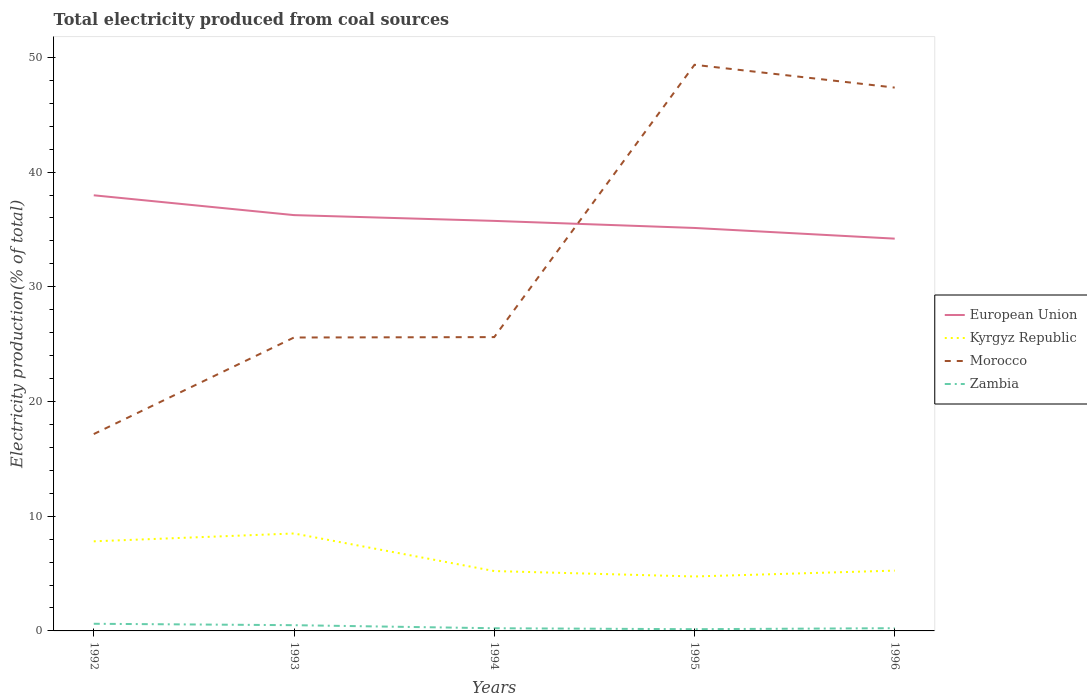How many different coloured lines are there?
Offer a very short reply. 4. Does the line corresponding to Morocco intersect with the line corresponding to Kyrgyz Republic?
Provide a succinct answer. No. Is the number of lines equal to the number of legend labels?
Give a very brief answer. Yes. Across all years, what is the maximum total electricity produced in Morocco?
Your response must be concise. 17.16. What is the total total electricity produced in Zambia in the graph?
Your response must be concise. 0.27. What is the difference between the highest and the second highest total electricity produced in Zambia?
Give a very brief answer. 0.47. What is the difference between the highest and the lowest total electricity produced in Morocco?
Make the answer very short. 2. Is the total electricity produced in Kyrgyz Republic strictly greater than the total electricity produced in European Union over the years?
Ensure brevity in your answer.  Yes. Are the values on the major ticks of Y-axis written in scientific E-notation?
Give a very brief answer. No. Does the graph contain grids?
Your answer should be compact. No. How are the legend labels stacked?
Provide a short and direct response. Vertical. What is the title of the graph?
Make the answer very short. Total electricity produced from coal sources. Does "Low income" appear as one of the legend labels in the graph?
Your answer should be compact. No. What is the label or title of the X-axis?
Your answer should be compact. Years. What is the label or title of the Y-axis?
Ensure brevity in your answer.  Electricity production(% of total). What is the Electricity production(% of total) of European Union in 1992?
Offer a very short reply. 37.98. What is the Electricity production(% of total) in Kyrgyz Republic in 1992?
Your answer should be very brief. 7.81. What is the Electricity production(% of total) in Morocco in 1992?
Keep it short and to the point. 17.16. What is the Electricity production(% of total) in Zambia in 1992?
Offer a terse response. 0.62. What is the Electricity production(% of total) in European Union in 1993?
Offer a very short reply. 36.25. What is the Electricity production(% of total) in Kyrgyz Republic in 1993?
Your answer should be very brief. 8.5. What is the Electricity production(% of total) in Morocco in 1993?
Provide a succinct answer. 25.58. What is the Electricity production(% of total) of Zambia in 1993?
Offer a very short reply. 0.5. What is the Electricity production(% of total) in European Union in 1994?
Offer a very short reply. 35.75. What is the Electricity production(% of total) of Kyrgyz Republic in 1994?
Offer a very short reply. 5.22. What is the Electricity production(% of total) in Morocco in 1994?
Offer a very short reply. 25.61. What is the Electricity production(% of total) in Zambia in 1994?
Give a very brief answer. 0.23. What is the Electricity production(% of total) in European Union in 1995?
Make the answer very short. 35.13. What is the Electricity production(% of total) of Kyrgyz Republic in 1995?
Offer a terse response. 4.75. What is the Electricity production(% of total) of Morocco in 1995?
Keep it short and to the point. 49.35. What is the Electricity production(% of total) in Zambia in 1995?
Provide a succinct answer. 0.15. What is the Electricity production(% of total) in European Union in 1996?
Offer a very short reply. 34.2. What is the Electricity production(% of total) in Kyrgyz Republic in 1996?
Your response must be concise. 5.26. What is the Electricity production(% of total) in Morocco in 1996?
Offer a very short reply. 47.37. What is the Electricity production(% of total) of Zambia in 1996?
Offer a very short reply. 0.24. Across all years, what is the maximum Electricity production(% of total) in European Union?
Provide a succinct answer. 37.98. Across all years, what is the maximum Electricity production(% of total) in Kyrgyz Republic?
Offer a very short reply. 8.5. Across all years, what is the maximum Electricity production(% of total) in Morocco?
Make the answer very short. 49.35. Across all years, what is the maximum Electricity production(% of total) in Zambia?
Your response must be concise. 0.62. Across all years, what is the minimum Electricity production(% of total) in European Union?
Make the answer very short. 34.2. Across all years, what is the minimum Electricity production(% of total) in Kyrgyz Republic?
Give a very brief answer. 4.75. Across all years, what is the minimum Electricity production(% of total) of Morocco?
Your response must be concise. 17.16. Across all years, what is the minimum Electricity production(% of total) of Zambia?
Provide a succinct answer. 0.15. What is the total Electricity production(% of total) of European Union in the graph?
Your answer should be very brief. 179.31. What is the total Electricity production(% of total) in Kyrgyz Republic in the graph?
Ensure brevity in your answer.  31.53. What is the total Electricity production(% of total) in Morocco in the graph?
Offer a terse response. 165.08. What is the total Electricity production(% of total) of Zambia in the graph?
Give a very brief answer. 1.75. What is the difference between the Electricity production(% of total) of European Union in 1992 and that in 1993?
Give a very brief answer. 1.73. What is the difference between the Electricity production(% of total) in Kyrgyz Republic in 1992 and that in 1993?
Ensure brevity in your answer.  -0.69. What is the difference between the Electricity production(% of total) in Morocco in 1992 and that in 1993?
Your answer should be compact. -8.42. What is the difference between the Electricity production(% of total) in Zambia in 1992 and that in 1993?
Offer a very short reply. 0.12. What is the difference between the Electricity production(% of total) of European Union in 1992 and that in 1994?
Your response must be concise. 2.23. What is the difference between the Electricity production(% of total) of Kyrgyz Republic in 1992 and that in 1994?
Make the answer very short. 2.59. What is the difference between the Electricity production(% of total) of Morocco in 1992 and that in 1994?
Make the answer very short. -8.45. What is the difference between the Electricity production(% of total) of Zambia in 1992 and that in 1994?
Your answer should be compact. 0.39. What is the difference between the Electricity production(% of total) in European Union in 1992 and that in 1995?
Provide a short and direct response. 2.85. What is the difference between the Electricity production(% of total) in Kyrgyz Republic in 1992 and that in 1995?
Give a very brief answer. 3.06. What is the difference between the Electricity production(% of total) of Morocco in 1992 and that in 1995?
Your answer should be compact. -32.19. What is the difference between the Electricity production(% of total) in Zambia in 1992 and that in 1995?
Give a very brief answer. 0.47. What is the difference between the Electricity production(% of total) in European Union in 1992 and that in 1996?
Ensure brevity in your answer.  3.78. What is the difference between the Electricity production(% of total) in Kyrgyz Republic in 1992 and that in 1996?
Keep it short and to the point. 2.55. What is the difference between the Electricity production(% of total) in Morocco in 1992 and that in 1996?
Offer a terse response. -30.21. What is the difference between the Electricity production(% of total) of Zambia in 1992 and that in 1996?
Provide a short and direct response. 0.39. What is the difference between the Electricity production(% of total) in European Union in 1993 and that in 1994?
Your answer should be very brief. 0.5. What is the difference between the Electricity production(% of total) in Kyrgyz Republic in 1993 and that in 1994?
Your answer should be compact. 3.28. What is the difference between the Electricity production(% of total) of Morocco in 1993 and that in 1994?
Your answer should be compact. -0.03. What is the difference between the Electricity production(% of total) of Zambia in 1993 and that in 1994?
Ensure brevity in your answer.  0.27. What is the difference between the Electricity production(% of total) in European Union in 1993 and that in 1995?
Your answer should be very brief. 1.12. What is the difference between the Electricity production(% of total) in Kyrgyz Republic in 1993 and that in 1995?
Offer a terse response. 3.75. What is the difference between the Electricity production(% of total) in Morocco in 1993 and that in 1995?
Your response must be concise. -23.77. What is the difference between the Electricity production(% of total) in Zambia in 1993 and that in 1995?
Offer a very short reply. 0.35. What is the difference between the Electricity production(% of total) in European Union in 1993 and that in 1996?
Offer a very short reply. 2.05. What is the difference between the Electricity production(% of total) of Kyrgyz Republic in 1993 and that in 1996?
Provide a succinct answer. 3.24. What is the difference between the Electricity production(% of total) of Morocco in 1993 and that in 1996?
Your answer should be very brief. -21.79. What is the difference between the Electricity production(% of total) in Zambia in 1993 and that in 1996?
Your response must be concise. 0.26. What is the difference between the Electricity production(% of total) of European Union in 1994 and that in 1995?
Make the answer very short. 0.62. What is the difference between the Electricity production(% of total) in Kyrgyz Republic in 1994 and that in 1995?
Ensure brevity in your answer.  0.47. What is the difference between the Electricity production(% of total) of Morocco in 1994 and that in 1995?
Offer a terse response. -23.74. What is the difference between the Electricity production(% of total) of Zambia in 1994 and that in 1995?
Offer a terse response. 0.08. What is the difference between the Electricity production(% of total) in European Union in 1994 and that in 1996?
Make the answer very short. 1.55. What is the difference between the Electricity production(% of total) in Kyrgyz Republic in 1994 and that in 1996?
Your answer should be compact. -0.04. What is the difference between the Electricity production(% of total) in Morocco in 1994 and that in 1996?
Your answer should be very brief. -21.75. What is the difference between the Electricity production(% of total) in Zambia in 1994 and that in 1996?
Your answer should be very brief. -0. What is the difference between the Electricity production(% of total) of European Union in 1995 and that in 1996?
Make the answer very short. 0.93. What is the difference between the Electricity production(% of total) in Kyrgyz Republic in 1995 and that in 1996?
Provide a succinct answer. -0.51. What is the difference between the Electricity production(% of total) in Morocco in 1995 and that in 1996?
Your response must be concise. 1.99. What is the difference between the Electricity production(% of total) in Zambia in 1995 and that in 1996?
Keep it short and to the point. -0.09. What is the difference between the Electricity production(% of total) of European Union in 1992 and the Electricity production(% of total) of Kyrgyz Republic in 1993?
Your answer should be very brief. 29.48. What is the difference between the Electricity production(% of total) in European Union in 1992 and the Electricity production(% of total) in Morocco in 1993?
Give a very brief answer. 12.4. What is the difference between the Electricity production(% of total) of European Union in 1992 and the Electricity production(% of total) of Zambia in 1993?
Keep it short and to the point. 37.48. What is the difference between the Electricity production(% of total) of Kyrgyz Republic in 1992 and the Electricity production(% of total) of Morocco in 1993?
Provide a short and direct response. -17.77. What is the difference between the Electricity production(% of total) of Kyrgyz Republic in 1992 and the Electricity production(% of total) of Zambia in 1993?
Your answer should be very brief. 7.31. What is the difference between the Electricity production(% of total) in Morocco in 1992 and the Electricity production(% of total) in Zambia in 1993?
Offer a very short reply. 16.66. What is the difference between the Electricity production(% of total) in European Union in 1992 and the Electricity production(% of total) in Kyrgyz Republic in 1994?
Your answer should be very brief. 32.76. What is the difference between the Electricity production(% of total) of European Union in 1992 and the Electricity production(% of total) of Morocco in 1994?
Your answer should be very brief. 12.36. What is the difference between the Electricity production(% of total) in European Union in 1992 and the Electricity production(% of total) in Zambia in 1994?
Give a very brief answer. 37.74. What is the difference between the Electricity production(% of total) of Kyrgyz Republic in 1992 and the Electricity production(% of total) of Morocco in 1994?
Your answer should be compact. -17.8. What is the difference between the Electricity production(% of total) in Kyrgyz Republic in 1992 and the Electricity production(% of total) in Zambia in 1994?
Offer a very short reply. 7.58. What is the difference between the Electricity production(% of total) in Morocco in 1992 and the Electricity production(% of total) in Zambia in 1994?
Offer a very short reply. 16.93. What is the difference between the Electricity production(% of total) in European Union in 1992 and the Electricity production(% of total) in Kyrgyz Republic in 1995?
Offer a terse response. 33.23. What is the difference between the Electricity production(% of total) of European Union in 1992 and the Electricity production(% of total) of Morocco in 1995?
Provide a short and direct response. -11.38. What is the difference between the Electricity production(% of total) of European Union in 1992 and the Electricity production(% of total) of Zambia in 1995?
Your response must be concise. 37.83. What is the difference between the Electricity production(% of total) of Kyrgyz Republic in 1992 and the Electricity production(% of total) of Morocco in 1995?
Give a very brief answer. -41.54. What is the difference between the Electricity production(% of total) of Kyrgyz Republic in 1992 and the Electricity production(% of total) of Zambia in 1995?
Your answer should be very brief. 7.66. What is the difference between the Electricity production(% of total) of Morocco in 1992 and the Electricity production(% of total) of Zambia in 1995?
Keep it short and to the point. 17.01. What is the difference between the Electricity production(% of total) in European Union in 1992 and the Electricity production(% of total) in Kyrgyz Republic in 1996?
Make the answer very short. 32.72. What is the difference between the Electricity production(% of total) of European Union in 1992 and the Electricity production(% of total) of Morocco in 1996?
Provide a short and direct response. -9.39. What is the difference between the Electricity production(% of total) in European Union in 1992 and the Electricity production(% of total) in Zambia in 1996?
Your answer should be compact. 37.74. What is the difference between the Electricity production(% of total) in Kyrgyz Republic in 1992 and the Electricity production(% of total) in Morocco in 1996?
Offer a very short reply. -39.56. What is the difference between the Electricity production(% of total) of Kyrgyz Republic in 1992 and the Electricity production(% of total) of Zambia in 1996?
Provide a short and direct response. 7.57. What is the difference between the Electricity production(% of total) of Morocco in 1992 and the Electricity production(% of total) of Zambia in 1996?
Offer a terse response. 16.93. What is the difference between the Electricity production(% of total) in European Union in 1993 and the Electricity production(% of total) in Kyrgyz Republic in 1994?
Provide a succinct answer. 31.03. What is the difference between the Electricity production(% of total) of European Union in 1993 and the Electricity production(% of total) of Morocco in 1994?
Keep it short and to the point. 10.64. What is the difference between the Electricity production(% of total) in European Union in 1993 and the Electricity production(% of total) in Zambia in 1994?
Make the answer very short. 36.02. What is the difference between the Electricity production(% of total) in Kyrgyz Republic in 1993 and the Electricity production(% of total) in Morocco in 1994?
Ensure brevity in your answer.  -17.12. What is the difference between the Electricity production(% of total) of Kyrgyz Republic in 1993 and the Electricity production(% of total) of Zambia in 1994?
Your answer should be very brief. 8.26. What is the difference between the Electricity production(% of total) in Morocco in 1993 and the Electricity production(% of total) in Zambia in 1994?
Ensure brevity in your answer.  25.35. What is the difference between the Electricity production(% of total) in European Union in 1993 and the Electricity production(% of total) in Kyrgyz Republic in 1995?
Your answer should be compact. 31.5. What is the difference between the Electricity production(% of total) in European Union in 1993 and the Electricity production(% of total) in Morocco in 1995?
Provide a succinct answer. -13.1. What is the difference between the Electricity production(% of total) of European Union in 1993 and the Electricity production(% of total) of Zambia in 1995?
Give a very brief answer. 36.1. What is the difference between the Electricity production(% of total) in Kyrgyz Republic in 1993 and the Electricity production(% of total) in Morocco in 1995?
Provide a succinct answer. -40.86. What is the difference between the Electricity production(% of total) in Kyrgyz Republic in 1993 and the Electricity production(% of total) in Zambia in 1995?
Make the answer very short. 8.34. What is the difference between the Electricity production(% of total) in Morocco in 1993 and the Electricity production(% of total) in Zambia in 1995?
Offer a very short reply. 25.43. What is the difference between the Electricity production(% of total) of European Union in 1993 and the Electricity production(% of total) of Kyrgyz Republic in 1996?
Provide a succinct answer. 30.99. What is the difference between the Electricity production(% of total) of European Union in 1993 and the Electricity production(% of total) of Morocco in 1996?
Ensure brevity in your answer.  -11.12. What is the difference between the Electricity production(% of total) of European Union in 1993 and the Electricity production(% of total) of Zambia in 1996?
Provide a succinct answer. 36.01. What is the difference between the Electricity production(% of total) of Kyrgyz Republic in 1993 and the Electricity production(% of total) of Morocco in 1996?
Provide a succinct answer. -38.87. What is the difference between the Electricity production(% of total) of Kyrgyz Republic in 1993 and the Electricity production(% of total) of Zambia in 1996?
Make the answer very short. 8.26. What is the difference between the Electricity production(% of total) of Morocco in 1993 and the Electricity production(% of total) of Zambia in 1996?
Ensure brevity in your answer.  25.34. What is the difference between the Electricity production(% of total) in European Union in 1994 and the Electricity production(% of total) in Kyrgyz Republic in 1995?
Make the answer very short. 31. What is the difference between the Electricity production(% of total) of European Union in 1994 and the Electricity production(% of total) of Morocco in 1995?
Offer a very short reply. -13.61. What is the difference between the Electricity production(% of total) of European Union in 1994 and the Electricity production(% of total) of Zambia in 1995?
Give a very brief answer. 35.6. What is the difference between the Electricity production(% of total) of Kyrgyz Republic in 1994 and the Electricity production(% of total) of Morocco in 1995?
Provide a succinct answer. -44.14. What is the difference between the Electricity production(% of total) of Kyrgyz Republic in 1994 and the Electricity production(% of total) of Zambia in 1995?
Ensure brevity in your answer.  5.07. What is the difference between the Electricity production(% of total) of Morocco in 1994 and the Electricity production(% of total) of Zambia in 1995?
Keep it short and to the point. 25.46. What is the difference between the Electricity production(% of total) in European Union in 1994 and the Electricity production(% of total) in Kyrgyz Republic in 1996?
Provide a succinct answer. 30.49. What is the difference between the Electricity production(% of total) of European Union in 1994 and the Electricity production(% of total) of Morocco in 1996?
Provide a short and direct response. -11.62. What is the difference between the Electricity production(% of total) in European Union in 1994 and the Electricity production(% of total) in Zambia in 1996?
Keep it short and to the point. 35.51. What is the difference between the Electricity production(% of total) in Kyrgyz Republic in 1994 and the Electricity production(% of total) in Morocco in 1996?
Offer a terse response. -42.15. What is the difference between the Electricity production(% of total) in Kyrgyz Republic in 1994 and the Electricity production(% of total) in Zambia in 1996?
Give a very brief answer. 4.98. What is the difference between the Electricity production(% of total) of Morocco in 1994 and the Electricity production(% of total) of Zambia in 1996?
Offer a very short reply. 25.38. What is the difference between the Electricity production(% of total) in European Union in 1995 and the Electricity production(% of total) in Kyrgyz Republic in 1996?
Provide a succinct answer. 29.87. What is the difference between the Electricity production(% of total) of European Union in 1995 and the Electricity production(% of total) of Morocco in 1996?
Provide a succinct answer. -12.24. What is the difference between the Electricity production(% of total) in European Union in 1995 and the Electricity production(% of total) in Zambia in 1996?
Provide a short and direct response. 34.89. What is the difference between the Electricity production(% of total) in Kyrgyz Republic in 1995 and the Electricity production(% of total) in Morocco in 1996?
Offer a very short reply. -42.62. What is the difference between the Electricity production(% of total) in Kyrgyz Republic in 1995 and the Electricity production(% of total) in Zambia in 1996?
Your response must be concise. 4.51. What is the difference between the Electricity production(% of total) in Morocco in 1995 and the Electricity production(% of total) in Zambia in 1996?
Offer a very short reply. 49.12. What is the average Electricity production(% of total) of European Union per year?
Offer a very short reply. 35.86. What is the average Electricity production(% of total) of Kyrgyz Republic per year?
Provide a succinct answer. 6.31. What is the average Electricity production(% of total) of Morocco per year?
Offer a very short reply. 33.02. What is the average Electricity production(% of total) of Zambia per year?
Your answer should be compact. 0.35. In the year 1992, what is the difference between the Electricity production(% of total) in European Union and Electricity production(% of total) in Kyrgyz Republic?
Keep it short and to the point. 30.17. In the year 1992, what is the difference between the Electricity production(% of total) in European Union and Electricity production(% of total) in Morocco?
Offer a very short reply. 20.82. In the year 1992, what is the difference between the Electricity production(% of total) of European Union and Electricity production(% of total) of Zambia?
Offer a terse response. 37.35. In the year 1992, what is the difference between the Electricity production(% of total) in Kyrgyz Republic and Electricity production(% of total) in Morocco?
Give a very brief answer. -9.35. In the year 1992, what is the difference between the Electricity production(% of total) of Kyrgyz Republic and Electricity production(% of total) of Zambia?
Your response must be concise. 7.19. In the year 1992, what is the difference between the Electricity production(% of total) of Morocco and Electricity production(% of total) of Zambia?
Offer a very short reply. 16.54. In the year 1993, what is the difference between the Electricity production(% of total) of European Union and Electricity production(% of total) of Kyrgyz Republic?
Your response must be concise. 27.75. In the year 1993, what is the difference between the Electricity production(% of total) of European Union and Electricity production(% of total) of Morocco?
Provide a short and direct response. 10.67. In the year 1993, what is the difference between the Electricity production(% of total) of European Union and Electricity production(% of total) of Zambia?
Give a very brief answer. 35.75. In the year 1993, what is the difference between the Electricity production(% of total) in Kyrgyz Republic and Electricity production(% of total) in Morocco?
Provide a succinct answer. -17.08. In the year 1993, what is the difference between the Electricity production(% of total) in Kyrgyz Republic and Electricity production(% of total) in Zambia?
Provide a short and direct response. 8. In the year 1993, what is the difference between the Electricity production(% of total) in Morocco and Electricity production(% of total) in Zambia?
Make the answer very short. 25.08. In the year 1994, what is the difference between the Electricity production(% of total) in European Union and Electricity production(% of total) in Kyrgyz Republic?
Your answer should be very brief. 30.53. In the year 1994, what is the difference between the Electricity production(% of total) of European Union and Electricity production(% of total) of Morocco?
Provide a succinct answer. 10.13. In the year 1994, what is the difference between the Electricity production(% of total) in European Union and Electricity production(% of total) in Zambia?
Ensure brevity in your answer.  35.51. In the year 1994, what is the difference between the Electricity production(% of total) of Kyrgyz Republic and Electricity production(% of total) of Morocco?
Your answer should be compact. -20.4. In the year 1994, what is the difference between the Electricity production(% of total) of Kyrgyz Republic and Electricity production(% of total) of Zambia?
Your response must be concise. 4.99. In the year 1994, what is the difference between the Electricity production(% of total) in Morocco and Electricity production(% of total) in Zambia?
Make the answer very short. 25.38. In the year 1995, what is the difference between the Electricity production(% of total) of European Union and Electricity production(% of total) of Kyrgyz Republic?
Your response must be concise. 30.38. In the year 1995, what is the difference between the Electricity production(% of total) of European Union and Electricity production(% of total) of Morocco?
Your answer should be very brief. -14.22. In the year 1995, what is the difference between the Electricity production(% of total) of European Union and Electricity production(% of total) of Zambia?
Your answer should be compact. 34.98. In the year 1995, what is the difference between the Electricity production(% of total) of Kyrgyz Republic and Electricity production(% of total) of Morocco?
Provide a short and direct response. -44.61. In the year 1995, what is the difference between the Electricity production(% of total) of Kyrgyz Republic and Electricity production(% of total) of Zambia?
Keep it short and to the point. 4.59. In the year 1995, what is the difference between the Electricity production(% of total) of Morocco and Electricity production(% of total) of Zambia?
Your response must be concise. 49.2. In the year 1996, what is the difference between the Electricity production(% of total) in European Union and Electricity production(% of total) in Kyrgyz Republic?
Provide a succinct answer. 28.94. In the year 1996, what is the difference between the Electricity production(% of total) in European Union and Electricity production(% of total) in Morocco?
Your answer should be very brief. -13.17. In the year 1996, what is the difference between the Electricity production(% of total) in European Union and Electricity production(% of total) in Zambia?
Make the answer very short. 33.96. In the year 1996, what is the difference between the Electricity production(% of total) in Kyrgyz Republic and Electricity production(% of total) in Morocco?
Offer a terse response. -42.11. In the year 1996, what is the difference between the Electricity production(% of total) of Kyrgyz Republic and Electricity production(% of total) of Zambia?
Keep it short and to the point. 5.02. In the year 1996, what is the difference between the Electricity production(% of total) of Morocco and Electricity production(% of total) of Zambia?
Your answer should be very brief. 47.13. What is the ratio of the Electricity production(% of total) of European Union in 1992 to that in 1993?
Your answer should be very brief. 1.05. What is the ratio of the Electricity production(% of total) of Kyrgyz Republic in 1992 to that in 1993?
Provide a succinct answer. 0.92. What is the ratio of the Electricity production(% of total) in Morocco in 1992 to that in 1993?
Give a very brief answer. 0.67. What is the ratio of the Electricity production(% of total) in Zambia in 1992 to that in 1993?
Provide a short and direct response. 1.25. What is the ratio of the Electricity production(% of total) of European Union in 1992 to that in 1994?
Keep it short and to the point. 1.06. What is the ratio of the Electricity production(% of total) in Kyrgyz Republic in 1992 to that in 1994?
Ensure brevity in your answer.  1.5. What is the ratio of the Electricity production(% of total) of Morocco in 1992 to that in 1994?
Your answer should be very brief. 0.67. What is the ratio of the Electricity production(% of total) of Zambia in 1992 to that in 1994?
Give a very brief answer. 2.67. What is the ratio of the Electricity production(% of total) in European Union in 1992 to that in 1995?
Your response must be concise. 1.08. What is the ratio of the Electricity production(% of total) in Kyrgyz Republic in 1992 to that in 1995?
Offer a terse response. 1.65. What is the ratio of the Electricity production(% of total) in Morocco in 1992 to that in 1995?
Your answer should be compact. 0.35. What is the ratio of the Electricity production(% of total) of Zambia in 1992 to that in 1995?
Ensure brevity in your answer.  4.12. What is the ratio of the Electricity production(% of total) in European Union in 1992 to that in 1996?
Ensure brevity in your answer.  1.11. What is the ratio of the Electricity production(% of total) of Kyrgyz Republic in 1992 to that in 1996?
Your answer should be very brief. 1.49. What is the ratio of the Electricity production(% of total) of Morocco in 1992 to that in 1996?
Your answer should be very brief. 0.36. What is the ratio of the Electricity production(% of total) in Zambia in 1992 to that in 1996?
Offer a very short reply. 2.63. What is the ratio of the Electricity production(% of total) of European Union in 1993 to that in 1994?
Keep it short and to the point. 1.01. What is the ratio of the Electricity production(% of total) in Kyrgyz Republic in 1993 to that in 1994?
Provide a succinct answer. 1.63. What is the ratio of the Electricity production(% of total) in Morocco in 1993 to that in 1994?
Keep it short and to the point. 1. What is the ratio of the Electricity production(% of total) of Zambia in 1993 to that in 1994?
Your response must be concise. 2.14. What is the ratio of the Electricity production(% of total) of European Union in 1993 to that in 1995?
Provide a succinct answer. 1.03. What is the ratio of the Electricity production(% of total) of Kyrgyz Republic in 1993 to that in 1995?
Give a very brief answer. 1.79. What is the ratio of the Electricity production(% of total) in Morocco in 1993 to that in 1995?
Provide a short and direct response. 0.52. What is the ratio of the Electricity production(% of total) of Zambia in 1993 to that in 1995?
Your answer should be very brief. 3.3. What is the ratio of the Electricity production(% of total) in European Union in 1993 to that in 1996?
Provide a succinct answer. 1.06. What is the ratio of the Electricity production(% of total) of Kyrgyz Republic in 1993 to that in 1996?
Make the answer very short. 1.62. What is the ratio of the Electricity production(% of total) in Morocco in 1993 to that in 1996?
Provide a short and direct response. 0.54. What is the ratio of the Electricity production(% of total) in Zambia in 1993 to that in 1996?
Your answer should be compact. 2.11. What is the ratio of the Electricity production(% of total) in European Union in 1994 to that in 1995?
Your answer should be very brief. 1.02. What is the ratio of the Electricity production(% of total) in Kyrgyz Republic in 1994 to that in 1995?
Keep it short and to the point. 1.1. What is the ratio of the Electricity production(% of total) in Morocco in 1994 to that in 1995?
Offer a very short reply. 0.52. What is the ratio of the Electricity production(% of total) in Zambia in 1994 to that in 1995?
Give a very brief answer. 1.54. What is the ratio of the Electricity production(% of total) in European Union in 1994 to that in 1996?
Offer a terse response. 1.05. What is the ratio of the Electricity production(% of total) in Kyrgyz Republic in 1994 to that in 1996?
Offer a terse response. 0.99. What is the ratio of the Electricity production(% of total) of Morocco in 1994 to that in 1996?
Provide a succinct answer. 0.54. What is the ratio of the Electricity production(% of total) of Zambia in 1994 to that in 1996?
Your answer should be compact. 0.98. What is the ratio of the Electricity production(% of total) of European Union in 1995 to that in 1996?
Your answer should be compact. 1.03. What is the ratio of the Electricity production(% of total) in Kyrgyz Republic in 1995 to that in 1996?
Ensure brevity in your answer.  0.9. What is the ratio of the Electricity production(% of total) of Morocco in 1995 to that in 1996?
Ensure brevity in your answer.  1.04. What is the ratio of the Electricity production(% of total) in Zambia in 1995 to that in 1996?
Offer a terse response. 0.64. What is the difference between the highest and the second highest Electricity production(% of total) of European Union?
Keep it short and to the point. 1.73. What is the difference between the highest and the second highest Electricity production(% of total) of Kyrgyz Republic?
Your response must be concise. 0.69. What is the difference between the highest and the second highest Electricity production(% of total) in Morocco?
Make the answer very short. 1.99. What is the difference between the highest and the second highest Electricity production(% of total) in Zambia?
Offer a terse response. 0.12. What is the difference between the highest and the lowest Electricity production(% of total) of European Union?
Offer a very short reply. 3.78. What is the difference between the highest and the lowest Electricity production(% of total) in Kyrgyz Republic?
Your answer should be compact. 3.75. What is the difference between the highest and the lowest Electricity production(% of total) in Morocco?
Make the answer very short. 32.19. What is the difference between the highest and the lowest Electricity production(% of total) of Zambia?
Offer a terse response. 0.47. 